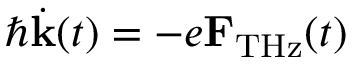<formula> <loc_0><loc_0><loc_500><loc_500>\hbar { \dot } { k } ( t ) = - e { F } _ { T H z } ( t )</formula> 